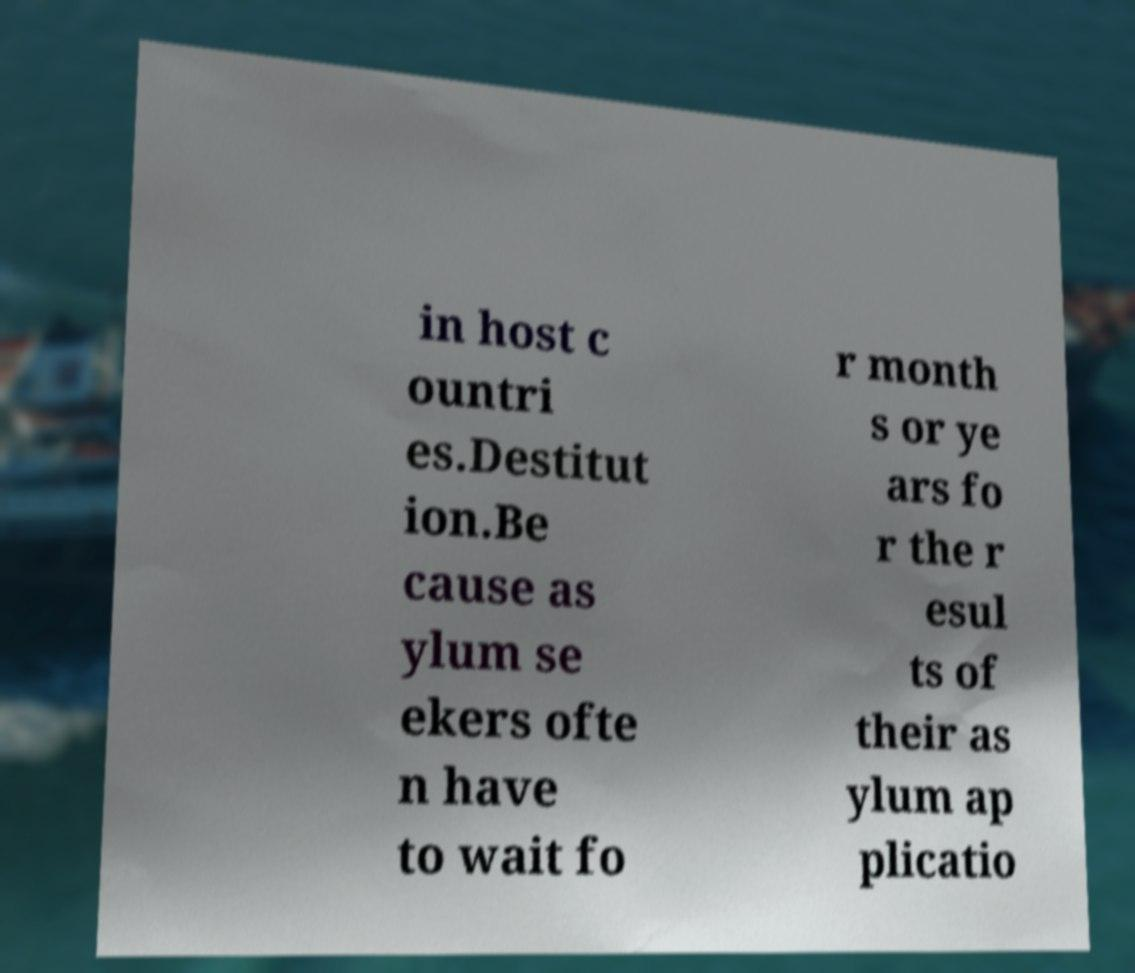What messages or text are displayed in this image? I need them in a readable, typed format. in host c ountri es.Destitut ion.Be cause as ylum se ekers ofte n have to wait fo r month s or ye ars fo r the r esul ts of their as ylum ap plicatio 